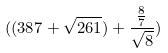<formula> <loc_0><loc_0><loc_500><loc_500>( ( 3 8 7 + \sqrt { 2 6 1 } ) + \frac { \frac { 8 } { 7 } } { \sqrt { 8 } } )</formula> 